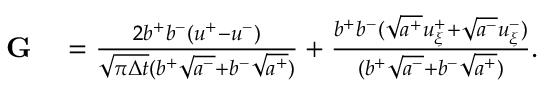Convert formula to latex. <formula><loc_0><loc_0><loc_500><loc_500>\begin{array} { r l } { G } & = \frac { 2 b ^ { + } b ^ { - } ( u ^ { + } - u ^ { - } ) } { \sqrt { \pi \Delta t } ( b ^ { + } \sqrt { a ^ { - } } + b ^ { - } \sqrt { a ^ { + } } ) } + \frac { b ^ { + } b ^ { - } ( \sqrt { a ^ { + } } u _ { \xi } ^ { + } + \sqrt { a ^ { - } } u _ { \xi } ^ { - } ) } { ( b ^ { + } \sqrt { a ^ { - } } + b ^ { - } \sqrt { a ^ { + } } ) } . } \end{array}</formula> 